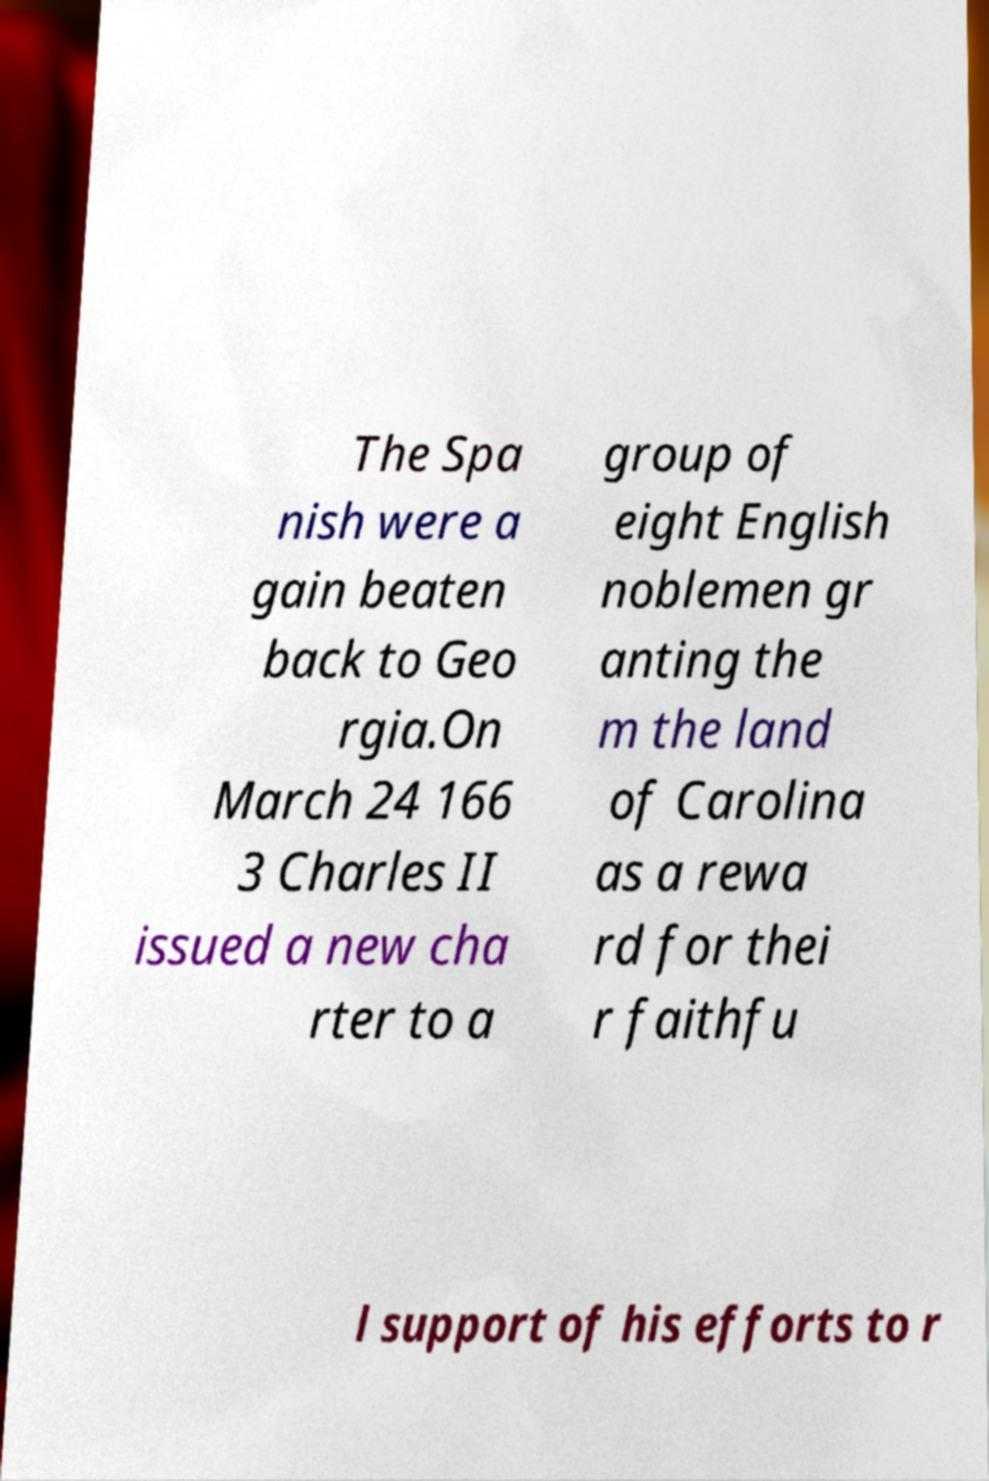Can you read and provide the text displayed in the image?This photo seems to have some interesting text. Can you extract and type it out for me? The Spa nish were a gain beaten back to Geo rgia.On March 24 166 3 Charles II issued a new cha rter to a group of eight English noblemen gr anting the m the land of Carolina as a rewa rd for thei r faithfu l support of his efforts to r 